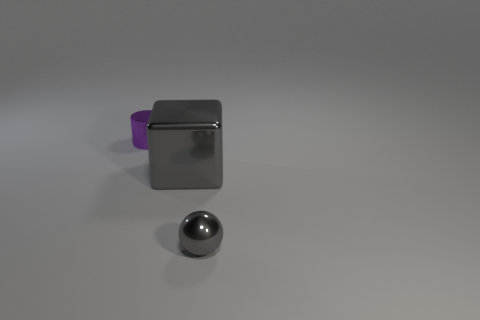There is a metallic object that is left of the metal block; is its size the same as the small metal sphere?
Provide a succinct answer. Yes. The object that is both left of the small gray object and on the right side of the purple shiny thing is what color?
Offer a terse response. Gray. What number of tiny gray objects are behind the tiny metal thing in front of the small purple object?
Provide a succinct answer. 0. Is there any other thing that is the same color as the tiny metallic cylinder?
Ensure brevity in your answer.  No. There is a tiny metallic thing behind the small thing that is on the right side of the gray metallic object that is left of the small gray sphere; what is its color?
Offer a terse response. Purple. Is the shape of the tiny thing that is behind the tiny gray sphere the same as  the big thing?
Provide a short and direct response. No. What is the material of the big thing?
Offer a terse response. Metal. What is the shape of the tiny shiny object left of the gray object that is behind the thing that is in front of the large object?
Your answer should be compact. Cylinder. How many other objects are the same shape as the small gray thing?
Keep it short and to the point. 0. Does the large metallic block have the same color as the small object left of the cube?
Give a very brief answer. No. 